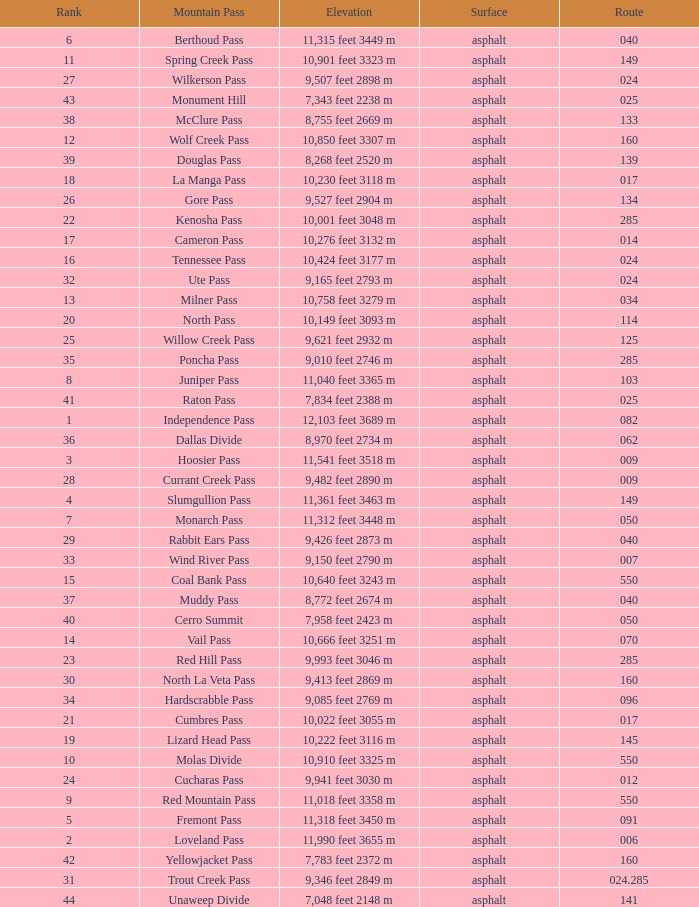What is the Surface of the Route less than 7? Asphalt. 